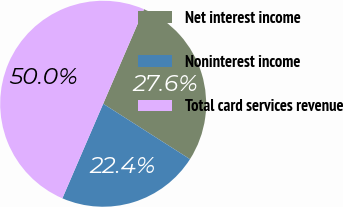Convert chart to OTSL. <chart><loc_0><loc_0><loc_500><loc_500><pie_chart><fcel>Net interest income<fcel>Noninterest income<fcel>Total card services revenue<nl><fcel>27.56%<fcel>22.44%<fcel>50.0%<nl></chart> 